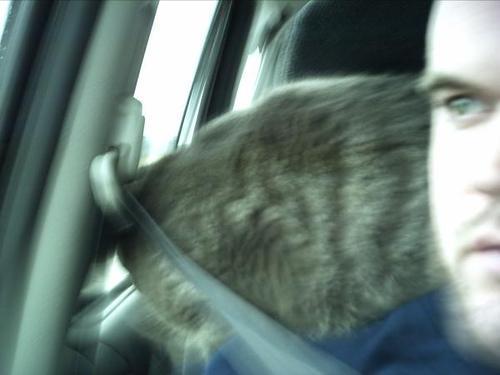How many people are there?
Give a very brief answer. 1. 